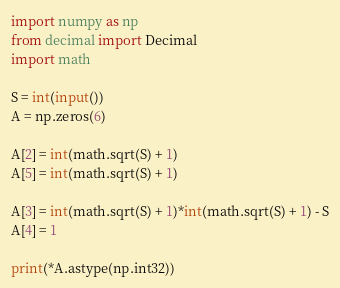Convert code to text. <code><loc_0><loc_0><loc_500><loc_500><_Python_>import numpy as np
from decimal import Decimal
import math

S = int(input())
A = np.zeros(6)

A[2] = int(math.sqrt(S) + 1)
A[5] = int(math.sqrt(S) + 1)

A[3] = int(math.sqrt(S) + 1)*int(math.sqrt(S) + 1) - S
A[4] = 1
    
print(*A.astype(np.int32))</code> 